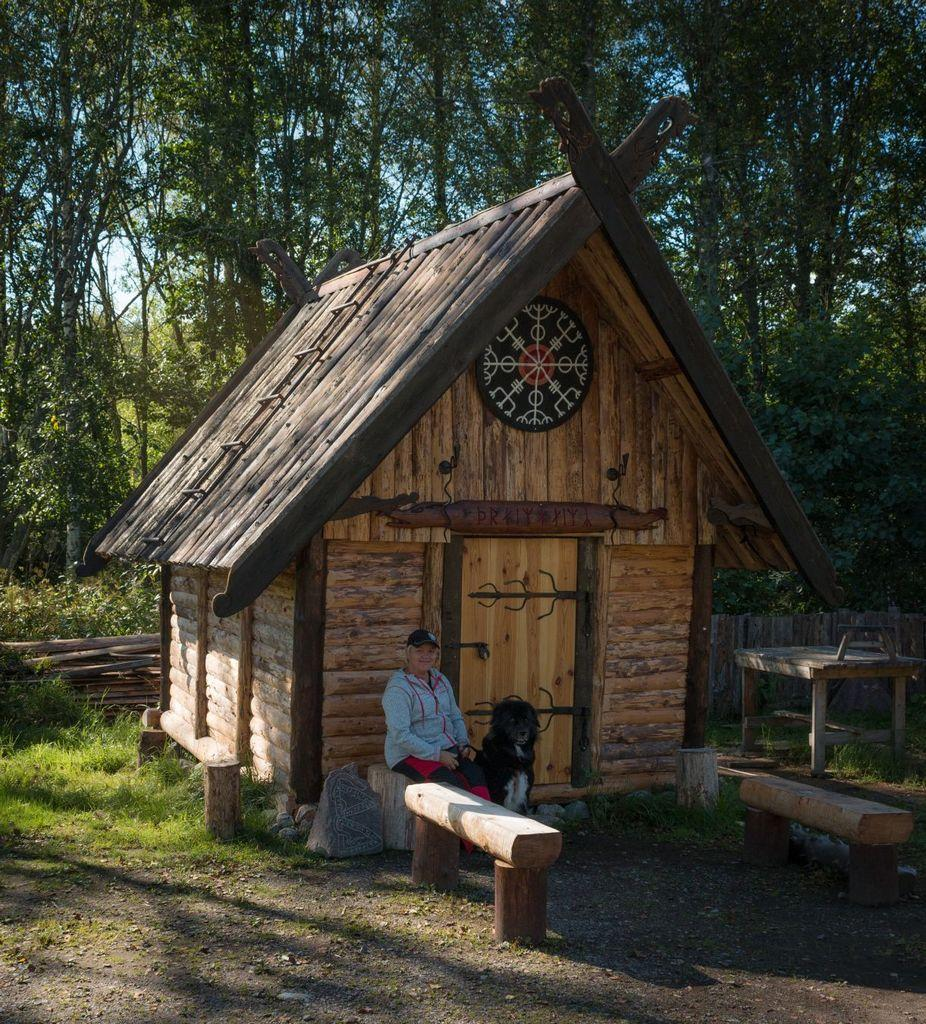What is the person in the image wearing on their head? The person in the image is wearing a cap. What is the person doing in the image? The person is sitting. What animal is present in the image? There is a dog in the image. What type of furniture can be seen in the image? There are benches and a table in the image. What type of structure is visible in the image? There is a house in the image. What architectural feature is present in the image? There is a door in the image. What type of natural environment is visible in the image? There is grass in the image. What type of barrier is present in the image? There is a fence in the image. What type of vegetation is visible in the image? There are trees in the image. What can be seen in the background of the image? The sky is visible in the background of the image. How many bananas can be seen in the image? There are no bananas present in the image. Can you describe the person's ability to jump in the image? The image does not show the person jumping, so it cannot be determined from the image. 